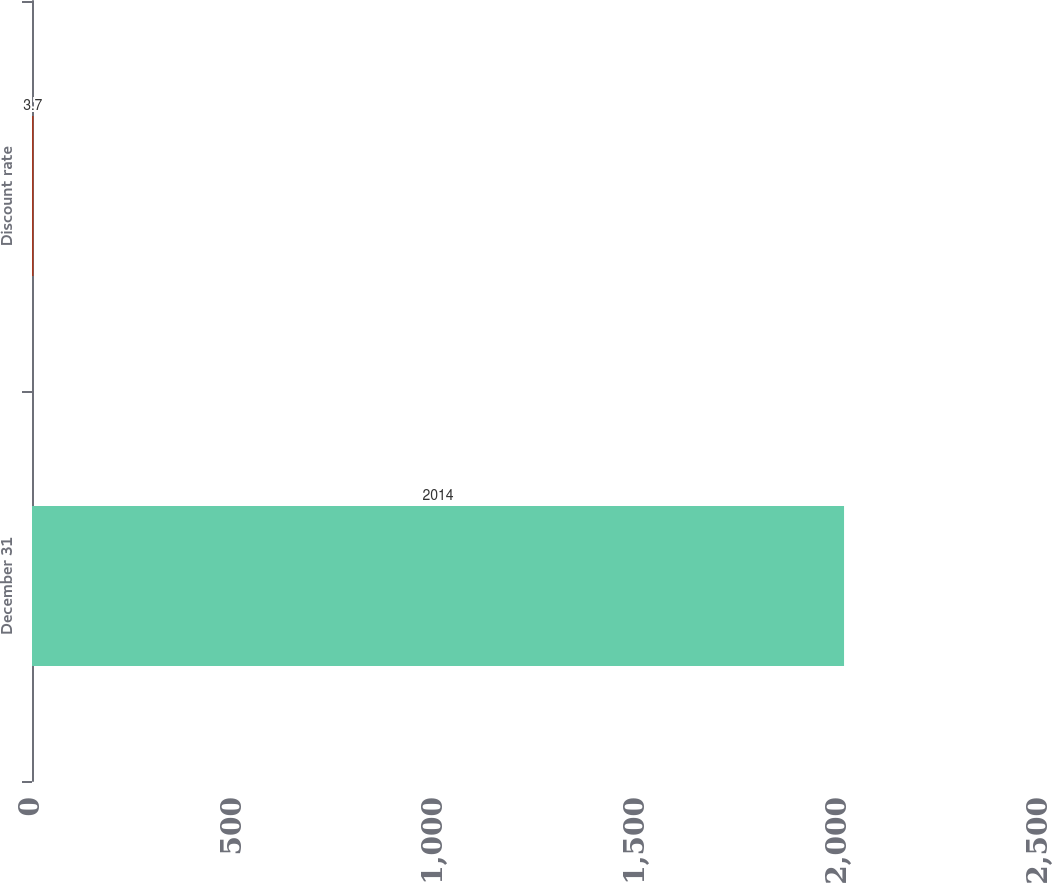<chart> <loc_0><loc_0><loc_500><loc_500><bar_chart><fcel>December 31<fcel>Discount rate<nl><fcel>2014<fcel>3.7<nl></chart> 